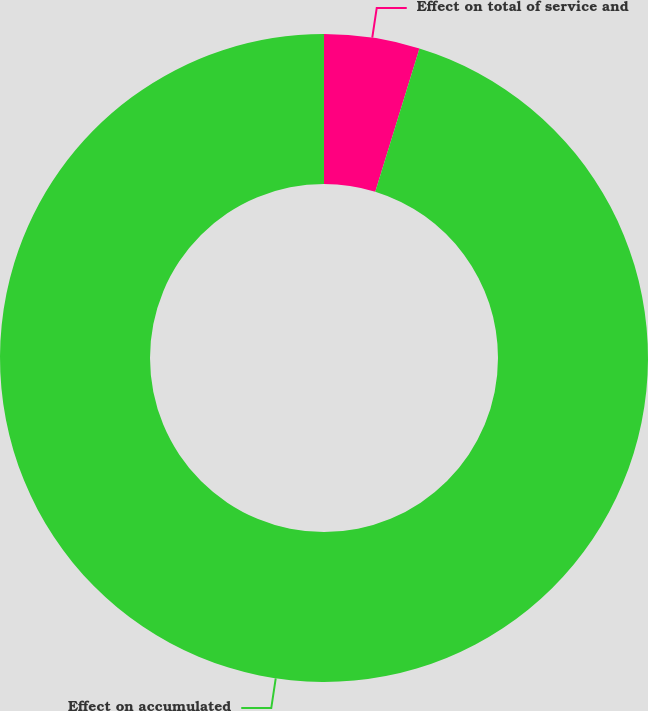Convert chart to OTSL. <chart><loc_0><loc_0><loc_500><loc_500><pie_chart><fcel>Effect on total of service and<fcel>Effect on accumulated<nl><fcel>4.76%<fcel>95.24%<nl></chart> 